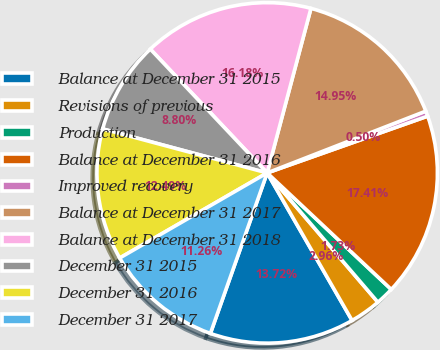Convert chart. <chart><loc_0><loc_0><loc_500><loc_500><pie_chart><fcel>Balance at December 31 2015<fcel>Revisions of previous<fcel>Production<fcel>Balance at December 31 2016<fcel>Improved recovery<fcel>Balance at December 31 2017<fcel>Balance at December 31 2018<fcel>December 31 2015<fcel>December 31 2016<fcel>December 31 2017<nl><fcel>13.72%<fcel>2.96%<fcel>1.73%<fcel>17.41%<fcel>0.5%<fcel>14.95%<fcel>16.18%<fcel>8.8%<fcel>12.49%<fcel>11.26%<nl></chart> 